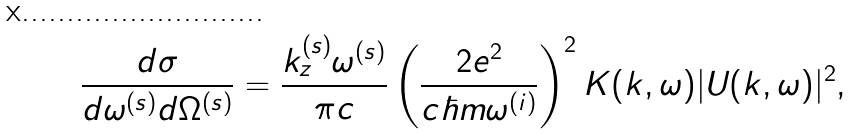Convert formula to latex. <formula><loc_0><loc_0><loc_500><loc_500>\frac { d \sigma } { d \omega ^ { ( s ) } d \Omega ^ { ( s ) } } = { \frac { k _ { z } ^ { ( s ) } \omega ^ { ( s ) } } { \pi c } } \left ( \frac { 2 e ^ { 2 } } { c \hbar { m } \omega ^ { ( i ) } } \right ) ^ { 2 } K ( { k } , \omega ) | U ( { k } , \omega ) | ^ { 2 } ,</formula> 